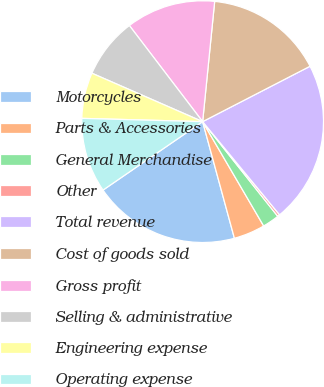Convert chart. <chart><loc_0><loc_0><loc_500><loc_500><pie_chart><fcel>Motorcycles<fcel>Parts & Accessories<fcel>General Merchandise<fcel>Other<fcel>Total revenue<fcel>Cost of goods sold<fcel>Gross profit<fcel>Selling & administrative<fcel>Engineering expense<fcel>Operating expense<nl><fcel>19.65%<fcel>4.19%<fcel>2.25%<fcel>0.31%<fcel>21.59%<fcel>15.83%<fcel>11.95%<fcel>8.07%<fcel>6.13%<fcel>10.01%<nl></chart> 